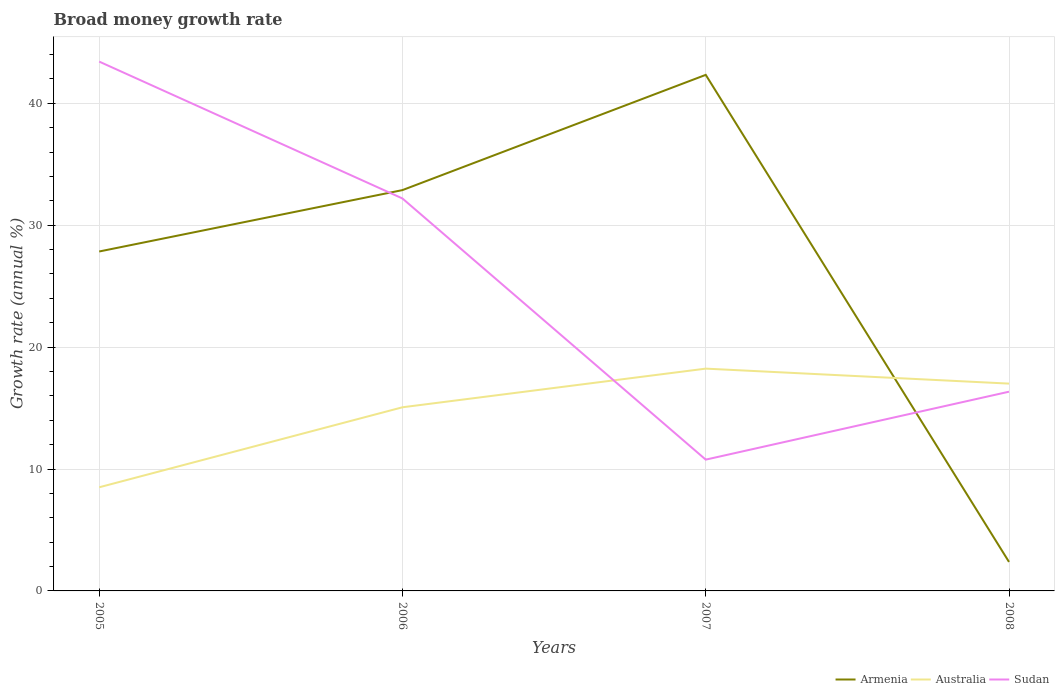How many different coloured lines are there?
Provide a succinct answer. 3. Does the line corresponding to Australia intersect with the line corresponding to Sudan?
Provide a short and direct response. Yes. Across all years, what is the maximum growth rate in Australia?
Your answer should be very brief. 8.5. In which year was the growth rate in Armenia maximum?
Make the answer very short. 2008. What is the total growth rate in Armenia in the graph?
Offer a terse response. 30.5. What is the difference between the highest and the second highest growth rate in Sudan?
Make the answer very short. 32.65. What is the difference between the highest and the lowest growth rate in Armenia?
Ensure brevity in your answer.  3. How many lines are there?
Your answer should be compact. 3. How many years are there in the graph?
Your answer should be compact. 4. Where does the legend appear in the graph?
Your response must be concise. Bottom right. How are the legend labels stacked?
Your answer should be compact. Horizontal. What is the title of the graph?
Your response must be concise. Broad money growth rate. What is the label or title of the Y-axis?
Make the answer very short. Growth rate (annual %). What is the Growth rate (annual %) in Armenia in 2005?
Make the answer very short. 27.84. What is the Growth rate (annual %) of Australia in 2005?
Ensure brevity in your answer.  8.5. What is the Growth rate (annual %) in Sudan in 2005?
Your response must be concise. 43.42. What is the Growth rate (annual %) of Armenia in 2006?
Provide a short and direct response. 32.88. What is the Growth rate (annual %) in Australia in 2006?
Offer a terse response. 15.06. What is the Growth rate (annual %) in Sudan in 2006?
Keep it short and to the point. 32.19. What is the Growth rate (annual %) in Armenia in 2007?
Keep it short and to the point. 42.33. What is the Growth rate (annual %) of Australia in 2007?
Provide a short and direct response. 18.23. What is the Growth rate (annual %) in Sudan in 2007?
Your answer should be very brief. 10.77. What is the Growth rate (annual %) in Armenia in 2008?
Provide a succinct answer. 2.38. What is the Growth rate (annual %) in Australia in 2008?
Offer a terse response. 17. What is the Growth rate (annual %) in Sudan in 2008?
Offer a very short reply. 16.34. Across all years, what is the maximum Growth rate (annual %) of Armenia?
Provide a short and direct response. 42.33. Across all years, what is the maximum Growth rate (annual %) in Australia?
Your response must be concise. 18.23. Across all years, what is the maximum Growth rate (annual %) in Sudan?
Provide a succinct answer. 43.42. Across all years, what is the minimum Growth rate (annual %) of Armenia?
Provide a short and direct response. 2.38. Across all years, what is the minimum Growth rate (annual %) of Australia?
Your response must be concise. 8.5. Across all years, what is the minimum Growth rate (annual %) in Sudan?
Offer a very short reply. 10.77. What is the total Growth rate (annual %) of Armenia in the graph?
Offer a terse response. 105.43. What is the total Growth rate (annual %) in Australia in the graph?
Give a very brief answer. 58.8. What is the total Growth rate (annual %) in Sudan in the graph?
Ensure brevity in your answer.  102.72. What is the difference between the Growth rate (annual %) in Armenia in 2005 and that in 2006?
Offer a terse response. -5.04. What is the difference between the Growth rate (annual %) of Australia in 2005 and that in 2006?
Provide a short and direct response. -6.56. What is the difference between the Growth rate (annual %) in Sudan in 2005 and that in 2006?
Keep it short and to the point. 11.23. What is the difference between the Growth rate (annual %) of Armenia in 2005 and that in 2007?
Your response must be concise. -14.49. What is the difference between the Growth rate (annual %) in Australia in 2005 and that in 2007?
Your answer should be very brief. -9.73. What is the difference between the Growth rate (annual %) of Sudan in 2005 and that in 2007?
Provide a short and direct response. 32.65. What is the difference between the Growth rate (annual %) of Armenia in 2005 and that in 2008?
Your answer should be compact. 25.46. What is the difference between the Growth rate (annual %) of Australia in 2005 and that in 2008?
Your response must be concise. -8.5. What is the difference between the Growth rate (annual %) of Sudan in 2005 and that in 2008?
Give a very brief answer. 27.08. What is the difference between the Growth rate (annual %) of Armenia in 2006 and that in 2007?
Give a very brief answer. -9.45. What is the difference between the Growth rate (annual %) in Australia in 2006 and that in 2007?
Offer a terse response. -3.17. What is the difference between the Growth rate (annual %) in Sudan in 2006 and that in 2007?
Your answer should be compact. 21.42. What is the difference between the Growth rate (annual %) in Armenia in 2006 and that in 2008?
Give a very brief answer. 30.5. What is the difference between the Growth rate (annual %) in Australia in 2006 and that in 2008?
Offer a very short reply. -1.94. What is the difference between the Growth rate (annual %) of Sudan in 2006 and that in 2008?
Offer a terse response. 15.85. What is the difference between the Growth rate (annual %) in Armenia in 2007 and that in 2008?
Offer a very short reply. 39.95. What is the difference between the Growth rate (annual %) of Australia in 2007 and that in 2008?
Provide a short and direct response. 1.23. What is the difference between the Growth rate (annual %) in Sudan in 2007 and that in 2008?
Offer a very short reply. -5.57. What is the difference between the Growth rate (annual %) in Armenia in 2005 and the Growth rate (annual %) in Australia in 2006?
Offer a terse response. 12.78. What is the difference between the Growth rate (annual %) in Armenia in 2005 and the Growth rate (annual %) in Sudan in 2006?
Keep it short and to the point. -4.35. What is the difference between the Growth rate (annual %) of Australia in 2005 and the Growth rate (annual %) of Sudan in 2006?
Make the answer very short. -23.69. What is the difference between the Growth rate (annual %) in Armenia in 2005 and the Growth rate (annual %) in Australia in 2007?
Your answer should be compact. 9.61. What is the difference between the Growth rate (annual %) in Armenia in 2005 and the Growth rate (annual %) in Sudan in 2007?
Keep it short and to the point. 17.07. What is the difference between the Growth rate (annual %) of Australia in 2005 and the Growth rate (annual %) of Sudan in 2007?
Your answer should be compact. -2.27. What is the difference between the Growth rate (annual %) in Armenia in 2005 and the Growth rate (annual %) in Australia in 2008?
Your answer should be very brief. 10.84. What is the difference between the Growth rate (annual %) in Armenia in 2005 and the Growth rate (annual %) in Sudan in 2008?
Provide a succinct answer. 11.5. What is the difference between the Growth rate (annual %) of Australia in 2005 and the Growth rate (annual %) of Sudan in 2008?
Make the answer very short. -7.84. What is the difference between the Growth rate (annual %) in Armenia in 2006 and the Growth rate (annual %) in Australia in 2007?
Offer a very short reply. 14.64. What is the difference between the Growth rate (annual %) of Armenia in 2006 and the Growth rate (annual %) of Sudan in 2007?
Your answer should be compact. 22.11. What is the difference between the Growth rate (annual %) of Australia in 2006 and the Growth rate (annual %) of Sudan in 2007?
Ensure brevity in your answer.  4.29. What is the difference between the Growth rate (annual %) of Armenia in 2006 and the Growth rate (annual %) of Australia in 2008?
Provide a succinct answer. 15.87. What is the difference between the Growth rate (annual %) in Armenia in 2006 and the Growth rate (annual %) in Sudan in 2008?
Your answer should be very brief. 16.54. What is the difference between the Growth rate (annual %) in Australia in 2006 and the Growth rate (annual %) in Sudan in 2008?
Offer a very short reply. -1.28. What is the difference between the Growth rate (annual %) of Armenia in 2007 and the Growth rate (annual %) of Australia in 2008?
Ensure brevity in your answer.  25.32. What is the difference between the Growth rate (annual %) in Armenia in 2007 and the Growth rate (annual %) in Sudan in 2008?
Ensure brevity in your answer.  25.99. What is the difference between the Growth rate (annual %) in Australia in 2007 and the Growth rate (annual %) in Sudan in 2008?
Offer a very short reply. 1.89. What is the average Growth rate (annual %) in Armenia per year?
Offer a very short reply. 26.36. What is the average Growth rate (annual %) in Australia per year?
Ensure brevity in your answer.  14.7. What is the average Growth rate (annual %) of Sudan per year?
Offer a very short reply. 25.68. In the year 2005, what is the difference between the Growth rate (annual %) of Armenia and Growth rate (annual %) of Australia?
Your response must be concise. 19.34. In the year 2005, what is the difference between the Growth rate (annual %) of Armenia and Growth rate (annual %) of Sudan?
Your answer should be compact. -15.58. In the year 2005, what is the difference between the Growth rate (annual %) of Australia and Growth rate (annual %) of Sudan?
Provide a succinct answer. -34.92. In the year 2006, what is the difference between the Growth rate (annual %) of Armenia and Growth rate (annual %) of Australia?
Keep it short and to the point. 17.81. In the year 2006, what is the difference between the Growth rate (annual %) in Armenia and Growth rate (annual %) in Sudan?
Ensure brevity in your answer.  0.69. In the year 2006, what is the difference between the Growth rate (annual %) in Australia and Growth rate (annual %) in Sudan?
Your answer should be very brief. -17.13. In the year 2007, what is the difference between the Growth rate (annual %) of Armenia and Growth rate (annual %) of Australia?
Your answer should be very brief. 24.1. In the year 2007, what is the difference between the Growth rate (annual %) of Armenia and Growth rate (annual %) of Sudan?
Offer a very short reply. 31.56. In the year 2007, what is the difference between the Growth rate (annual %) in Australia and Growth rate (annual %) in Sudan?
Provide a succinct answer. 7.46. In the year 2008, what is the difference between the Growth rate (annual %) in Armenia and Growth rate (annual %) in Australia?
Keep it short and to the point. -14.63. In the year 2008, what is the difference between the Growth rate (annual %) in Armenia and Growth rate (annual %) in Sudan?
Offer a very short reply. -13.96. In the year 2008, what is the difference between the Growth rate (annual %) of Australia and Growth rate (annual %) of Sudan?
Make the answer very short. 0.66. What is the ratio of the Growth rate (annual %) in Armenia in 2005 to that in 2006?
Your answer should be compact. 0.85. What is the ratio of the Growth rate (annual %) of Australia in 2005 to that in 2006?
Your answer should be compact. 0.56. What is the ratio of the Growth rate (annual %) of Sudan in 2005 to that in 2006?
Your answer should be very brief. 1.35. What is the ratio of the Growth rate (annual %) in Armenia in 2005 to that in 2007?
Offer a terse response. 0.66. What is the ratio of the Growth rate (annual %) in Australia in 2005 to that in 2007?
Provide a succinct answer. 0.47. What is the ratio of the Growth rate (annual %) of Sudan in 2005 to that in 2007?
Give a very brief answer. 4.03. What is the ratio of the Growth rate (annual %) of Armenia in 2005 to that in 2008?
Provide a succinct answer. 11.7. What is the ratio of the Growth rate (annual %) of Australia in 2005 to that in 2008?
Keep it short and to the point. 0.5. What is the ratio of the Growth rate (annual %) of Sudan in 2005 to that in 2008?
Give a very brief answer. 2.66. What is the ratio of the Growth rate (annual %) of Armenia in 2006 to that in 2007?
Provide a short and direct response. 0.78. What is the ratio of the Growth rate (annual %) in Australia in 2006 to that in 2007?
Make the answer very short. 0.83. What is the ratio of the Growth rate (annual %) of Sudan in 2006 to that in 2007?
Your response must be concise. 2.99. What is the ratio of the Growth rate (annual %) in Armenia in 2006 to that in 2008?
Offer a terse response. 13.82. What is the ratio of the Growth rate (annual %) of Australia in 2006 to that in 2008?
Your answer should be compact. 0.89. What is the ratio of the Growth rate (annual %) of Sudan in 2006 to that in 2008?
Your answer should be compact. 1.97. What is the ratio of the Growth rate (annual %) in Armenia in 2007 to that in 2008?
Give a very brief answer. 17.8. What is the ratio of the Growth rate (annual %) of Australia in 2007 to that in 2008?
Your answer should be compact. 1.07. What is the ratio of the Growth rate (annual %) of Sudan in 2007 to that in 2008?
Offer a terse response. 0.66. What is the difference between the highest and the second highest Growth rate (annual %) of Armenia?
Give a very brief answer. 9.45. What is the difference between the highest and the second highest Growth rate (annual %) of Australia?
Make the answer very short. 1.23. What is the difference between the highest and the second highest Growth rate (annual %) of Sudan?
Ensure brevity in your answer.  11.23. What is the difference between the highest and the lowest Growth rate (annual %) in Armenia?
Provide a short and direct response. 39.95. What is the difference between the highest and the lowest Growth rate (annual %) of Australia?
Keep it short and to the point. 9.73. What is the difference between the highest and the lowest Growth rate (annual %) of Sudan?
Give a very brief answer. 32.65. 